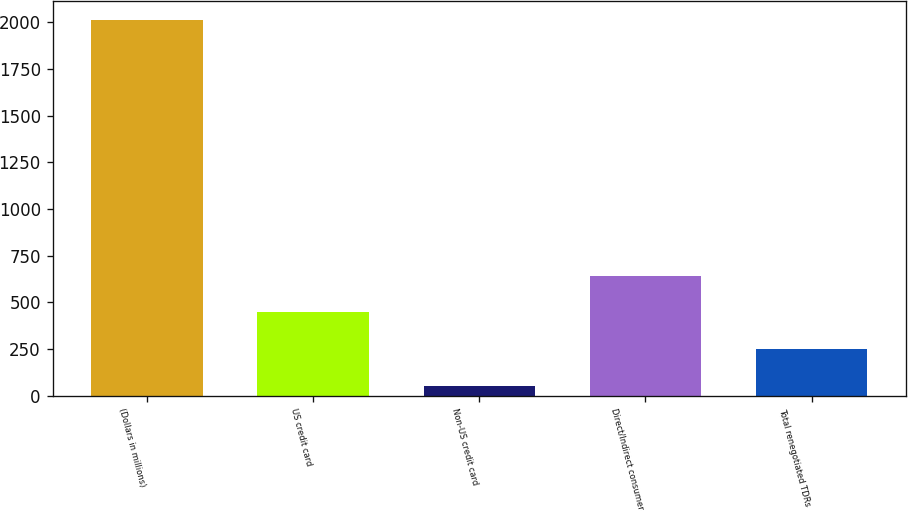<chart> <loc_0><loc_0><loc_500><loc_500><bar_chart><fcel>(Dollars in millions)<fcel>US credit card<fcel>Non-US credit card<fcel>Direct/Indirect consumer<fcel>Total renegotiated TDRs<nl><fcel>2011<fcel>445.42<fcel>54.02<fcel>641.12<fcel>249.72<nl></chart> 